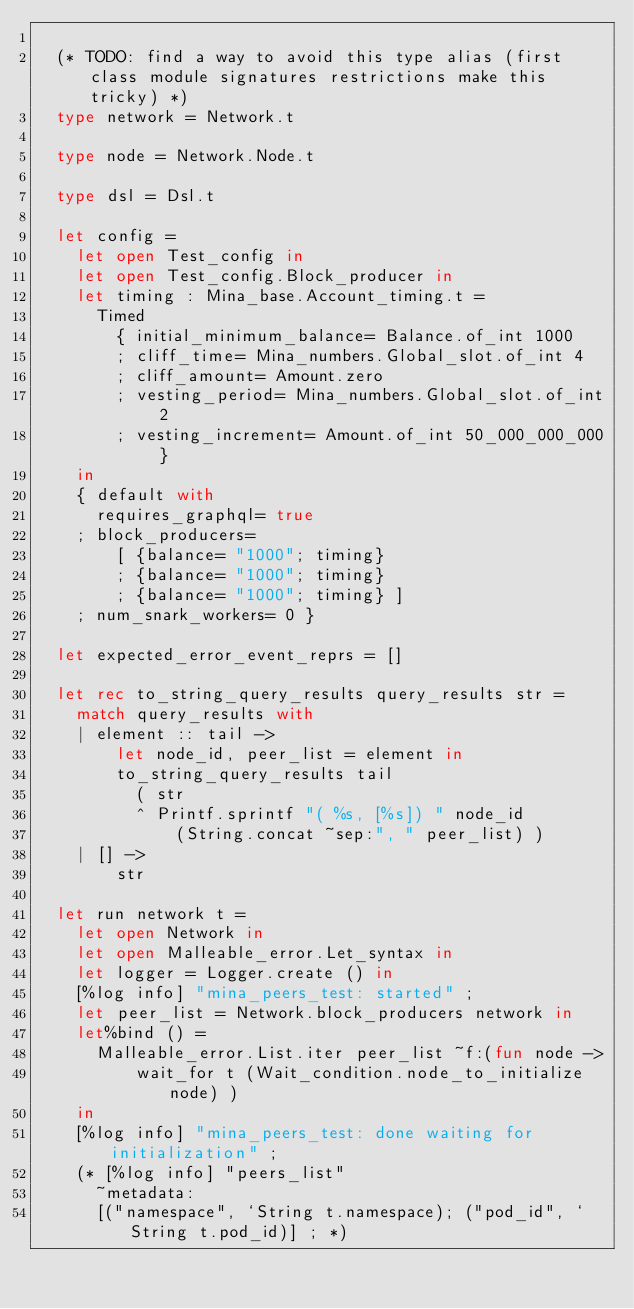<code> <loc_0><loc_0><loc_500><loc_500><_OCaml_>
  (* TODO: find a way to avoid this type alias (first class module signatures restrictions make this tricky) *)
  type network = Network.t

  type node = Network.Node.t

  type dsl = Dsl.t

  let config =
    let open Test_config in
    let open Test_config.Block_producer in
    let timing : Mina_base.Account_timing.t =
      Timed
        { initial_minimum_balance= Balance.of_int 1000
        ; cliff_time= Mina_numbers.Global_slot.of_int 4
        ; cliff_amount= Amount.zero
        ; vesting_period= Mina_numbers.Global_slot.of_int 2
        ; vesting_increment= Amount.of_int 50_000_000_000 }
    in
    { default with
      requires_graphql= true
    ; block_producers=
        [ {balance= "1000"; timing}
        ; {balance= "1000"; timing}
        ; {balance= "1000"; timing} ]
    ; num_snark_workers= 0 }

  let expected_error_event_reprs = []

  let rec to_string_query_results query_results str =
    match query_results with
    | element :: tail ->
        let node_id, peer_list = element in
        to_string_query_results tail
          ( str
          ^ Printf.sprintf "( %s, [%s]) " node_id
              (String.concat ~sep:", " peer_list) )
    | [] ->
        str

  let run network t =
    let open Network in
    let open Malleable_error.Let_syntax in
    let logger = Logger.create () in
    [%log info] "mina_peers_test: started" ;
    let peer_list = Network.block_producers network in
    let%bind () =
      Malleable_error.List.iter peer_list ~f:(fun node ->
          wait_for t (Wait_condition.node_to_initialize node) )
    in
    [%log info] "mina_peers_test: done waiting for initialization" ;
    (* [%log info] "peers_list"
      ~metadata:
      [("namespace", `String t.namespace); ("pod_id", `String t.pod_id)] ; *)</code> 